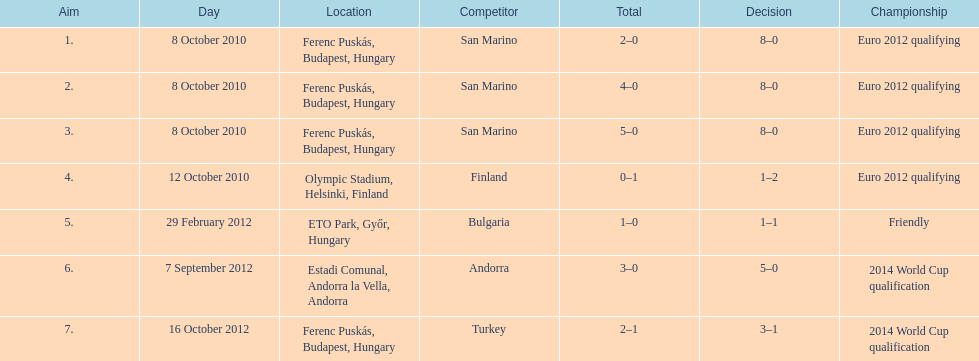In what year did ádám szalai make his next international goal after 2010? 2012. 